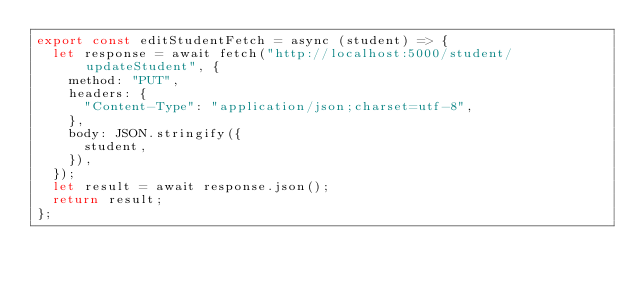<code> <loc_0><loc_0><loc_500><loc_500><_JavaScript_>export const editStudentFetch = async (student) => {
  let response = await fetch("http://localhost:5000/student/updateStudent", {
    method: "PUT",
    headers: {
      "Content-Type": "application/json;charset=utf-8",
    },
    body: JSON.stringify({
      student,
    }),
  });
  let result = await response.json();
  return result;
};
</code> 